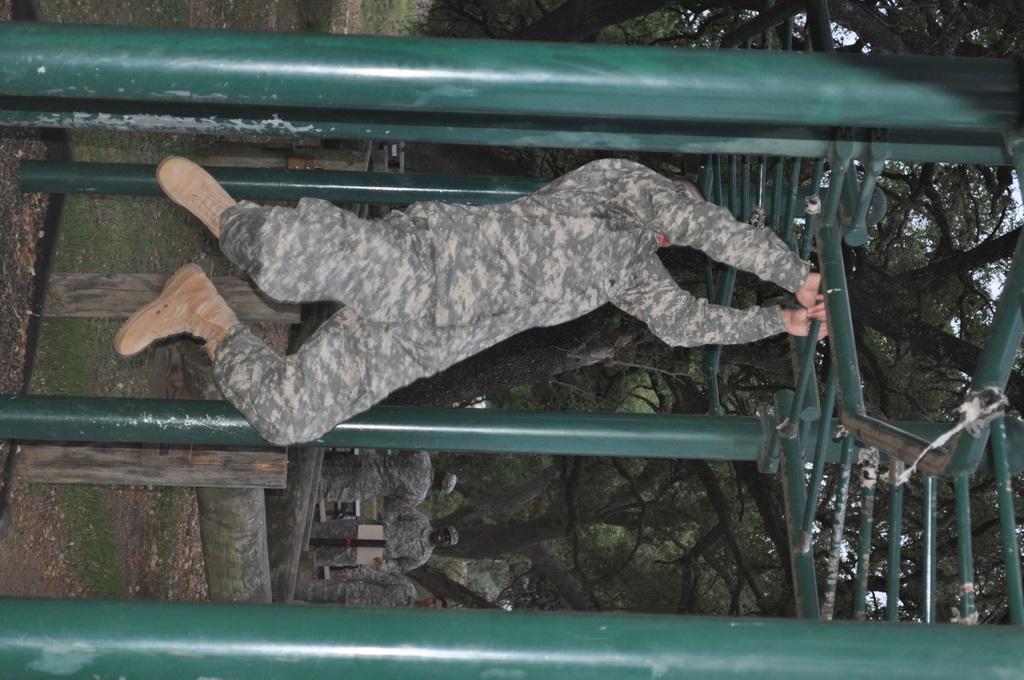Please provide a concise description of this image. In this picture there is a man in the center of the image, by holding a rod of a cage in his hands and there are trees and other men in the background area of the image. 